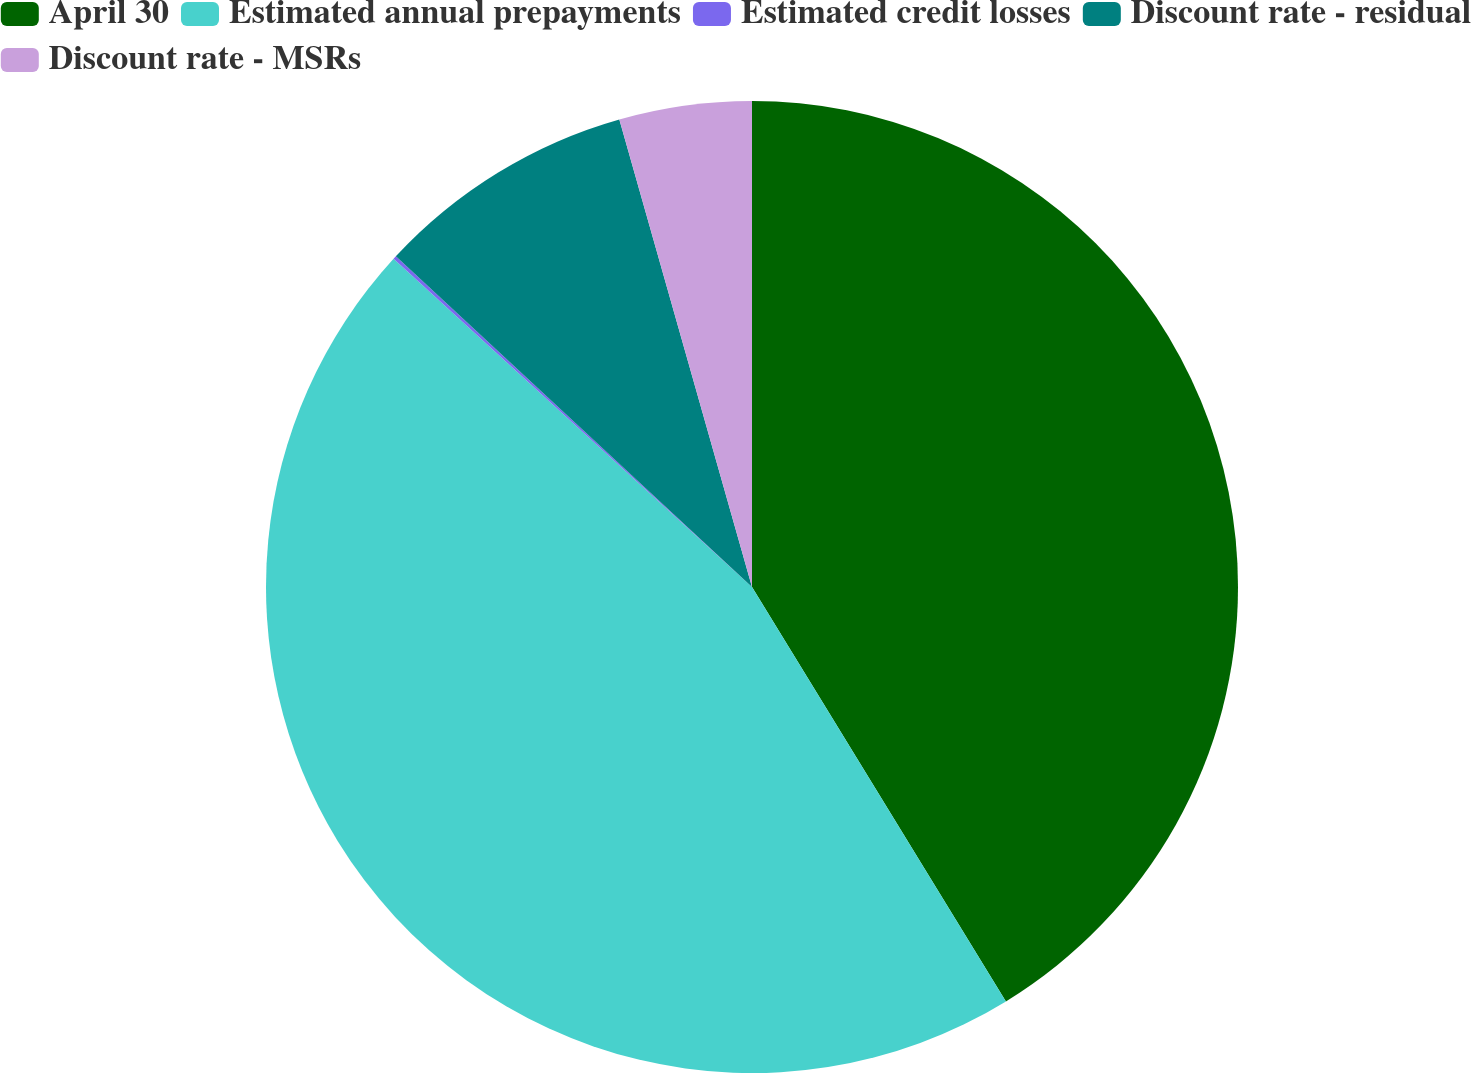<chart> <loc_0><loc_0><loc_500><loc_500><pie_chart><fcel>April 30<fcel>Estimated annual prepayments<fcel>Estimated credit losses<fcel>Discount rate - residual<fcel>Discount rate - MSRs<nl><fcel>41.25%<fcel>45.55%<fcel>0.11%<fcel>8.69%<fcel>4.4%<nl></chart> 